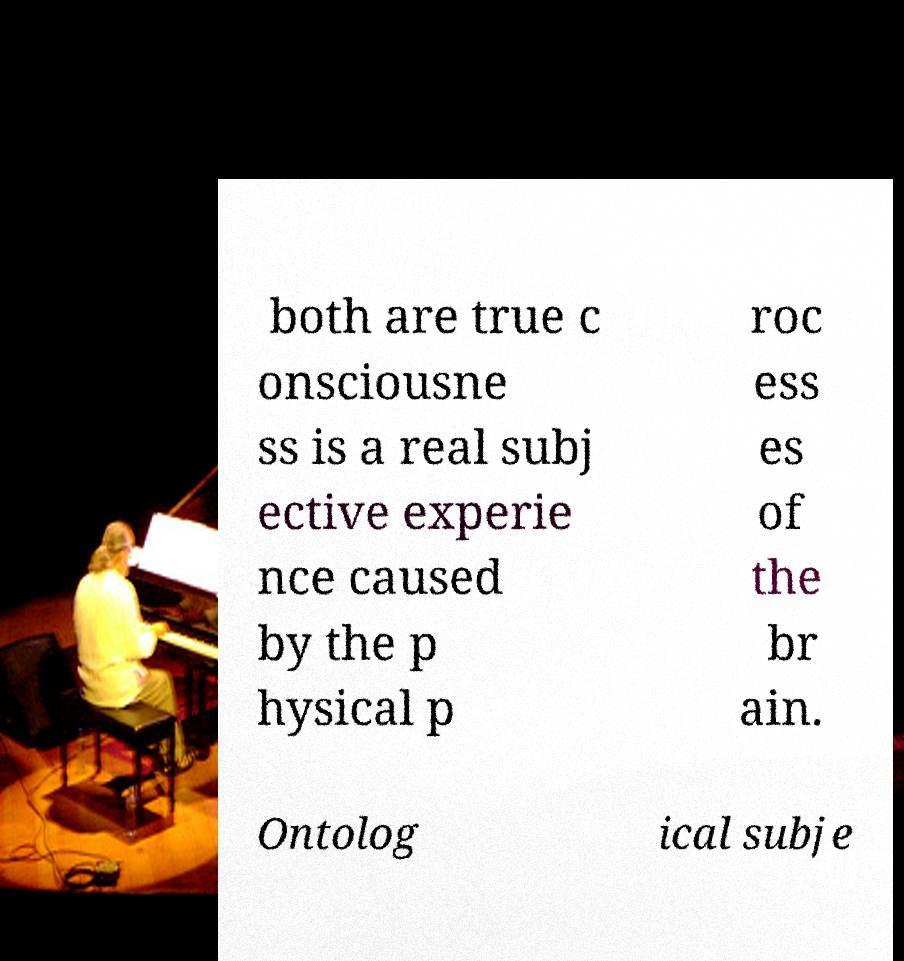Can you accurately transcribe the text from the provided image for me? both are true c onsciousne ss is a real subj ective experie nce caused by the p hysical p roc ess es of the br ain. Ontolog ical subje 